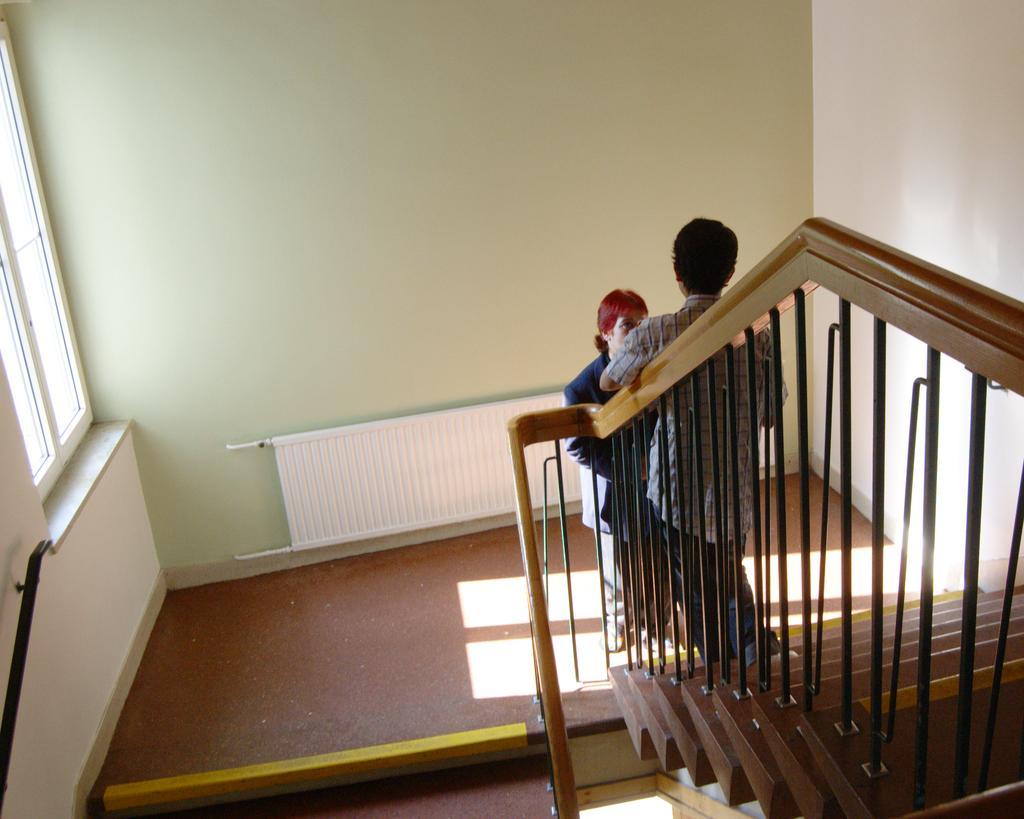Please provide a concise description of this image. There are two persons standing on the stairs as we can see at the bottom of this image, and there is a wall in the background. There is a window on the left side of this image. 